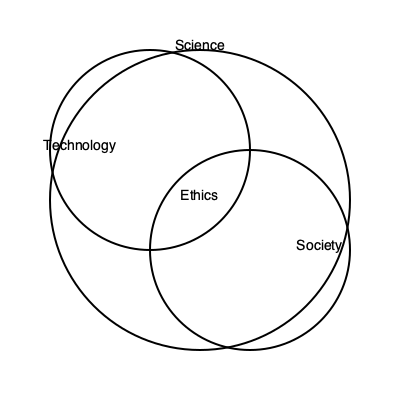In the Venn diagram above, which concept lies at the intersection of Science, Technology, and Society, challenging the deterministic view of their relationships? 1. The diagram shows three overlapping circles representing Science, Technology, and Society.

2. These circles create various intersections, symbolizing the interconnectedness of these systems.

3. The largest circle (Science) encompasses both Technology and Society, suggesting its overarching influence.

4. The intersection of all three circles is labeled "Ethics," indicating that ethical considerations are central to the interplay of science, technology, and society.

5. This placement of Ethics at the core challenges the deterministic view by suggesting that moral and philosophical considerations should guide the development and application of scientific and technological advancements in society.

6. It implies that the relationship between these domains is not purely causal or predetermined, but rather mediated by ethical deliberation.

7. This representation aligns with a philosophical perspective that questions the notion of technological determinism and emphasizes the role of human agency and values in shaping societal development.
Answer: Ethics 